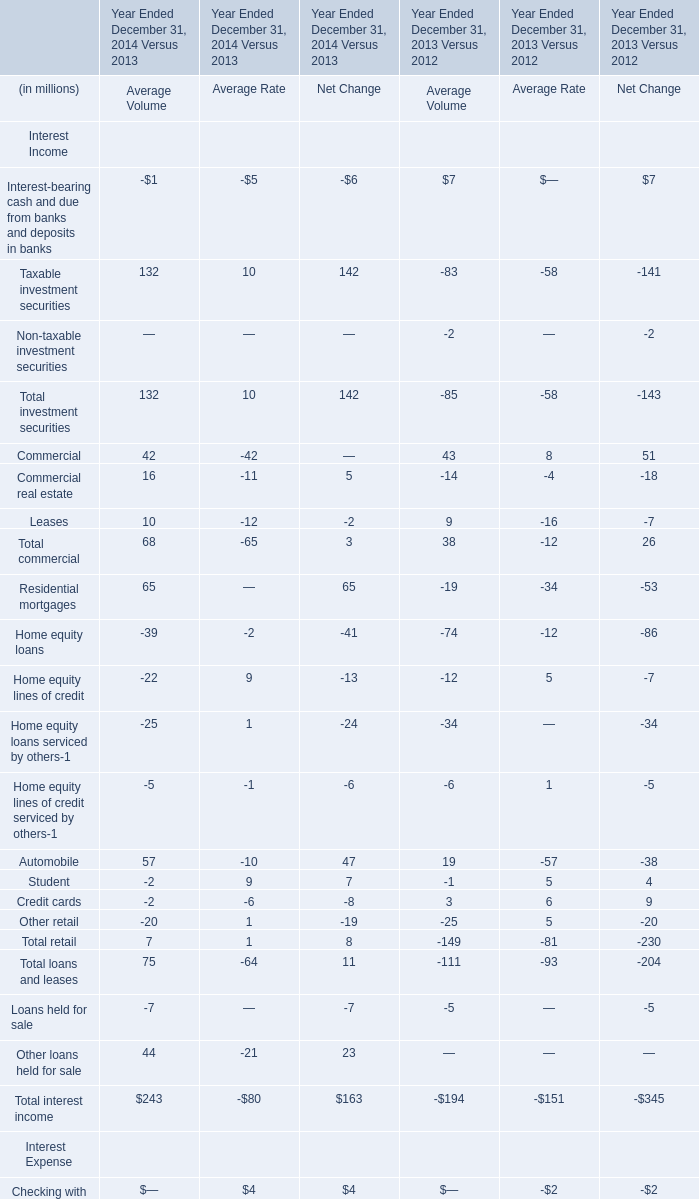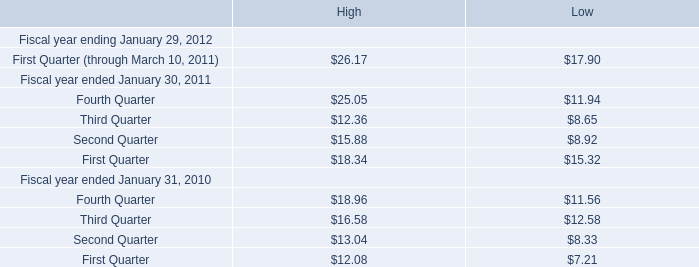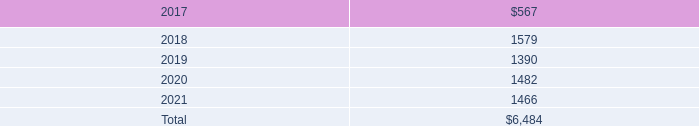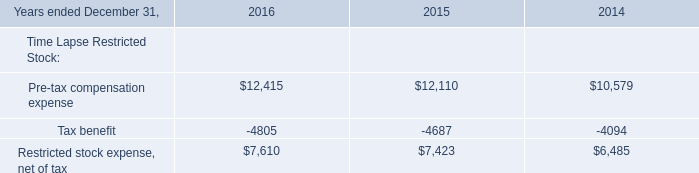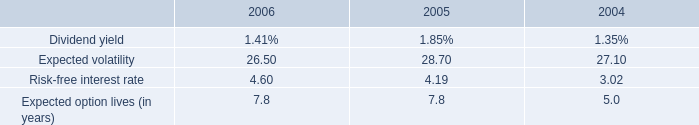what percent did the employee benefits expense increase between 2004 and 2006? 
Computations: ((208 - 74) / 74)
Answer: 1.81081. 